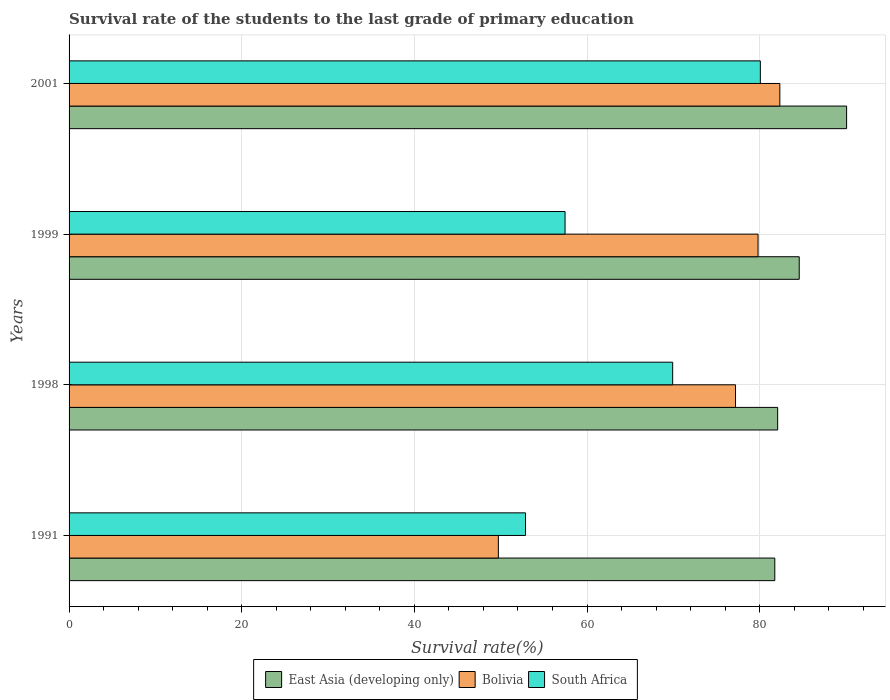How many different coloured bars are there?
Offer a terse response. 3. How many groups of bars are there?
Keep it short and to the point. 4. How many bars are there on the 2nd tick from the top?
Provide a succinct answer. 3. What is the label of the 1st group of bars from the top?
Provide a short and direct response. 2001. In how many cases, is the number of bars for a given year not equal to the number of legend labels?
Provide a short and direct response. 0. What is the survival rate of the students in Bolivia in 1991?
Offer a very short reply. 49.73. Across all years, what is the maximum survival rate of the students in Bolivia?
Give a very brief answer. 82.33. Across all years, what is the minimum survival rate of the students in East Asia (developing only)?
Your answer should be compact. 81.75. In which year was the survival rate of the students in East Asia (developing only) minimum?
Give a very brief answer. 1991. What is the total survival rate of the students in East Asia (developing only) in the graph?
Ensure brevity in your answer.  338.47. What is the difference between the survival rate of the students in Bolivia in 1998 and that in 2001?
Offer a very short reply. -5.13. What is the difference between the survival rate of the students in Bolivia in 1999 and the survival rate of the students in South Africa in 2001?
Your answer should be compact. -0.27. What is the average survival rate of the students in East Asia (developing only) per year?
Give a very brief answer. 84.62. In the year 1999, what is the difference between the survival rate of the students in Bolivia and survival rate of the students in South Africa?
Your response must be concise. 22.36. What is the ratio of the survival rate of the students in South Africa in 1999 to that in 2001?
Your answer should be compact. 0.72. What is the difference between the highest and the second highest survival rate of the students in Bolivia?
Give a very brief answer. 2.52. What is the difference between the highest and the lowest survival rate of the students in East Asia (developing only)?
Offer a very short reply. 8.32. In how many years, is the survival rate of the students in Bolivia greater than the average survival rate of the students in Bolivia taken over all years?
Your answer should be very brief. 3. What does the 3rd bar from the top in 1991 represents?
Keep it short and to the point. East Asia (developing only). What does the 3rd bar from the bottom in 1999 represents?
Give a very brief answer. South Africa. Is it the case that in every year, the sum of the survival rate of the students in Bolivia and survival rate of the students in East Asia (developing only) is greater than the survival rate of the students in South Africa?
Offer a very short reply. Yes. Are all the bars in the graph horizontal?
Offer a terse response. Yes. How many years are there in the graph?
Offer a terse response. 4. What is the difference between two consecutive major ticks on the X-axis?
Offer a terse response. 20. How are the legend labels stacked?
Offer a terse response. Horizontal. What is the title of the graph?
Ensure brevity in your answer.  Survival rate of the students to the last grade of primary education. What is the label or title of the X-axis?
Your response must be concise. Survival rate(%). What is the label or title of the Y-axis?
Offer a very short reply. Years. What is the Survival rate(%) of East Asia (developing only) in 1991?
Provide a short and direct response. 81.75. What is the Survival rate(%) in Bolivia in 1991?
Give a very brief answer. 49.73. What is the Survival rate(%) in South Africa in 1991?
Your response must be concise. 52.87. What is the Survival rate(%) in East Asia (developing only) in 1998?
Keep it short and to the point. 82.08. What is the Survival rate(%) in Bolivia in 1998?
Make the answer very short. 77.2. What is the Survival rate(%) of South Africa in 1998?
Provide a succinct answer. 69.92. What is the Survival rate(%) in East Asia (developing only) in 1999?
Give a very brief answer. 84.58. What is the Survival rate(%) of Bolivia in 1999?
Provide a short and direct response. 79.81. What is the Survival rate(%) in South Africa in 1999?
Ensure brevity in your answer.  57.45. What is the Survival rate(%) in East Asia (developing only) in 2001?
Offer a very short reply. 90.07. What is the Survival rate(%) of Bolivia in 2001?
Ensure brevity in your answer.  82.33. What is the Survival rate(%) of South Africa in 2001?
Make the answer very short. 80.07. Across all years, what is the maximum Survival rate(%) of East Asia (developing only)?
Give a very brief answer. 90.07. Across all years, what is the maximum Survival rate(%) in Bolivia?
Make the answer very short. 82.33. Across all years, what is the maximum Survival rate(%) in South Africa?
Ensure brevity in your answer.  80.07. Across all years, what is the minimum Survival rate(%) of East Asia (developing only)?
Your answer should be very brief. 81.75. Across all years, what is the minimum Survival rate(%) of Bolivia?
Provide a short and direct response. 49.73. Across all years, what is the minimum Survival rate(%) of South Africa?
Offer a terse response. 52.87. What is the total Survival rate(%) of East Asia (developing only) in the graph?
Offer a very short reply. 338.47. What is the total Survival rate(%) in Bolivia in the graph?
Ensure brevity in your answer.  289.06. What is the total Survival rate(%) in South Africa in the graph?
Ensure brevity in your answer.  260.31. What is the difference between the Survival rate(%) of East Asia (developing only) in 1991 and that in 1998?
Offer a very short reply. -0.33. What is the difference between the Survival rate(%) in Bolivia in 1991 and that in 1998?
Offer a terse response. -27.47. What is the difference between the Survival rate(%) in South Africa in 1991 and that in 1998?
Make the answer very short. -17.05. What is the difference between the Survival rate(%) in East Asia (developing only) in 1991 and that in 1999?
Ensure brevity in your answer.  -2.83. What is the difference between the Survival rate(%) in Bolivia in 1991 and that in 1999?
Offer a very short reply. -30.08. What is the difference between the Survival rate(%) in South Africa in 1991 and that in 1999?
Your answer should be compact. -4.58. What is the difference between the Survival rate(%) of East Asia (developing only) in 1991 and that in 2001?
Provide a short and direct response. -8.32. What is the difference between the Survival rate(%) of Bolivia in 1991 and that in 2001?
Your response must be concise. -32.6. What is the difference between the Survival rate(%) in South Africa in 1991 and that in 2001?
Ensure brevity in your answer.  -27.2. What is the difference between the Survival rate(%) of East Asia (developing only) in 1998 and that in 1999?
Provide a short and direct response. -2.5. What is the difference between the Survival rate(%) in Bolivia in 1998 and that in 1999?
Your answer should be compact. -2.61. What is the difference between the Survival rate(%) in South Africa in 1998 and that in 1999?
Provide a short and direct response. 12.47. What is the difference between the Survival rate(%) in East Asia (developing only) in 1998 and that in 2001?
Make the answer very short. -7.99. What is the difference between the Survival rate(%) in Bolivia in 1998 and that in 2001?
Your answer should be compact. -5.13. What is the difference between the Survival rate(%) of South Africa in 1998 and that in 2001?
Your answer should be very brief. -10.15. What is the difference between the Survival rate(%) in East Asia (developing only) in 1999 and that in 2001?
Offer a very short reply. -5.49. What is the difference between the Survival rate(%) in Bolivia in 1999 and that in 2001?
Offer a terse response. -2.52. What is the difference between the Survival rate(%) in South Africa in 1999 and that in 2001?
Ensure brevity in your answer.  -22.62. What is the difference between the Survival rate(%) in East Asia (developing only) in 1991 and the Survival rate(%) in Bolivia in 1998?
Provide a succinct answer. 4.55. What is the difference between the Survival rate(%) in East Asia (developing only) in 1991 and the Survival rate(%) in South Africa in 1998?
Offer a terse response. 11.83. What is the difference between the Survival rate(%) in Bolivia in 1991 and the Survival rate(%) in South Africa in 1998?
Make the answer very short. -20.19. What is the difference between the Survival rate(%) of East Asia (developing only) in 1991 and the Survival rate(%) of Bolivia in 1999?
Offer a very short reply. 1.94. What is the difference between the Survival rate(%) in East Asia (developing only) in 1991 and the Survival rate(%) in South Africa in 1999?
Keep it short and to the point. 24.3. What is the difference between the Survival rate(%) in Bolivia in 1991 and the Survival rate(%) in South Africa in 1999?
Offer a very short reply. -7.73. What is the difference between the Survival rate(%) in East Asia (developing only) in 1991 and the Survival rate(%) in Bolivia in 2001?
Make the answer very short. -0.58. What is the difference between the Survival rate(%) of East Asia (developing only) in 1991 and the Survival rate(%) of South Africa in 2001?
Your answer should be very brief. 1.67. What is the difference between the Survival rate(%) in Bolivia in 1991 and the Survival rate(%) in South Africa in 2001?
Provide a succinct answer. -30.35. What is the difference between the Survival rate(%) of East Asia (developing only) in 1998 and the Survival rate(%) of Bolivia in 1999?
Offer a very short reply. 2.27. What is the difference between the Survival rate(%) in East Asia (developing only) in 1998 and the Survival rate(%) in South Africa in 1999?
Give a very brief answer. 24.63. What is the difference between the Survival rate(%) of Bolivia in 1998 and the Survival rate(%) of South Africa in 1999?
Give a very brief answer. 19.75. What is the difference between the Survival rate(%) of East Asia (developing only) in 1998 and the Survival rate(%) of Bolivia in 2001?
Your answer should be compact. -0.25. What is the difference between the Survival rate(%) in East Asia (developing only) in 1998 and the Survival rate(%) in South Africa in 2001?
Provide a succinct answer. 2.01. What is the difference between the Survival rate(%) in Bolivia in 1998 and the Survival rate(%) in South Africa in 2001?
Offer a terse response. -2.88. What is the difference between the Survival rate(%) of East Asia (developing only) in 1999 and the Survival rate(%) of Bolivia in 2001?
Your answer should be compact. 2.25. What is the difference between the Survival rate(%) of East Asia (developing only) in 1999 and the Survival rate(%) of South Africa in 2001?
Your answer should be compact. 4.51. What is the difference between the Survival rate(%) in Bolivia in 1999 and the Survival rate(%) in South Africa in 2001?
Provide a short and direct response. -0.27. What is the average Survival rate(%) in East Asia (developing only) per year?
Give a very brief answer. 84.62. What is the average Survival rate(%) in Bolivia per year?
Provide a short and direct response. 72.27. What is the average Survival rate(%) in South Africa per year?
Provide a succinct answer. 65.08. In the year 1991, what is the difference between the Survival rate(%) in East Asia (developing only) and Survival rate(%) in Bolivia?
Make the answer very short. 32.02. In the year 1991, what is the difference between the Survival rate(%) of East Asia (developing only) and Survival rate(%) of South Africa?
Make the answer very short. 28.88. In the year 1991, what is the difference between the Survival rate(%) in Bolivia and Survival rate(%) in South Africa?
Provide a short and direct response. -3.14. In the year 1998, what is the difference between the Survival rate(%) of East Asia (developing only) and Survival rate(%) of Bolivia?
Provide a short and direct response. 4.88. In the year 1998, what is the difference between the Survival rate(%) of East Asia (developing only) and Survival rate(%) of South Africa?
Ensure brevity in your answer.  12.16. In the year 1998, what is the difference between the Survival rate(%) in Bolivia and Survival rate(%) in South Africa?
Provide a short and direct response. 7.28. In the year 1999, what is the difference between the Survival rate(%) of East Asia (developing only) and Survival rate(%) of Bolivia?
Your response must be concise. 4.77. In the year 1999, what is the difference between the Survival rate(%) of East Asia (developing only) and Survival rate(%) of South Africa?
Your response must be concise. 27.13. In the year 1999, what is the difference between the Survival rate(%) of Bolivia and Survival rate(%) of South Africa?
Keep it short and to the point. 22.36. In the year 2001, what is the difference between the Survival rate(%) of East Asia (developing only) and Survival rate(%) of Bolivia?
Your response must be concise. 7.74. In the year 2001, what is the difference between the Survival rate(%) of East Asia (developing only) and Survival rate(%) of South Africa?
Ensure brevity in your answer.  9.99. In the year 2001, what is the difference between the Survival rate(%) in Bolivia and Survival rate(%) in South Africa?
Your answer should be compact. 2.26. What is the ratio of the Survival rate(%) in East Asia (developing only) in 1991 to that in 1998?
Give a very brief answer. 1. What is the ratio of the Survival rate(%) in Bolivia in 1991 to that in 1998?
Make the answer very short. 0.64. What is the ratio of the Survival rate(%) of South Africa in 1991 to that in 1998?
Provide a succinct answer. 0.76. What is the ratio of the Survival rate(%) of East Asia (developing only) in 1991 to that in 1999?
Provide a short and direct response. 0.97. What is the ratio of the Survival rate(%) of Bolivia in 1991 to that in 1999?
Keep it short and to the point. 0.62. What is the ratio of the Survival rate(%) of South Africa in 1991 to that in 1999?
Give a very brief answer. 0.92. What is the ratio of the Survival rate(%) of East Asia (developing only) in 1991 to that in 2001?
Offer a terse response. 0.91. What is the ratio of the Survival rate(%) of Bolivia in 1991 to that in 2001?
Your answer should be compact. 0.6. What is the ratio of the Survival rate(%) of South Africa in 1991 to that in 2001?
Provide a short and direct response. 0.66. What is the ratio of the Survival rate(%) of East Asia (developing only) in 1998 to that in 1999?
Offer a very short reply. 0.97. What is the ratio of the Survival rate(%) of Bolivia in 1998 to that in 1999?
Provide a succinct answer. 0.97. What is the ratio of the Survival rate(%) in South Africa in 1998 to that in 1999?
Give a very brief answer. 1.22. What is the ratio of the Survival rate(%) of East Asia (developing only) in 1998 to that in 2001?
Offer a terse response. 0.91. What is the ratio of the Survival rate(%) of Bolivia in 1998 to that in 2001?
Offer a very short reply. 0.94. What is the ratio of the Survival rate(%) of South Africa in 1998 to that in 2001?
Make the answer very short. 0.87. What is the ratio of the Survival rate(%) in East Asia (developing only) in 1999 to that in 2001?
Give a very brief answer. 0.94. What is the ratio of the Survival rate(%) in Bolivia in 1999 to that in 2001?
Your response must be concise. 0.97. What is the ratio of the Survival rate(%) in South Africa in 1999 to that in 2001?
Offer a terse response. 0.72. What is the difference between the highest and the second highest Survival rate(%) of East Asia (developing only)?
Provide a succinct answer. 5.49. What is the difference between the highest and the second highest Survival rate(%) in Bolivia?
Your response must be concise. 2.52. What is the difference between the highest and the second highest Survival rate(%) of South Africa?
Your answer should be very brief. 10.15. What is the difference between the highest and the lowest Survival rate(%) of East Asia (developing only)?
Provide a short and direct response. 8.32. What is the difference between the highest and the lowest Survival rate(%) in Bolivia?
Your response must be concise. 32.6. What is the difference between the highest and the lowest Survival rate(%) of South Africa?
Keep it short and to the point. 27.2. 